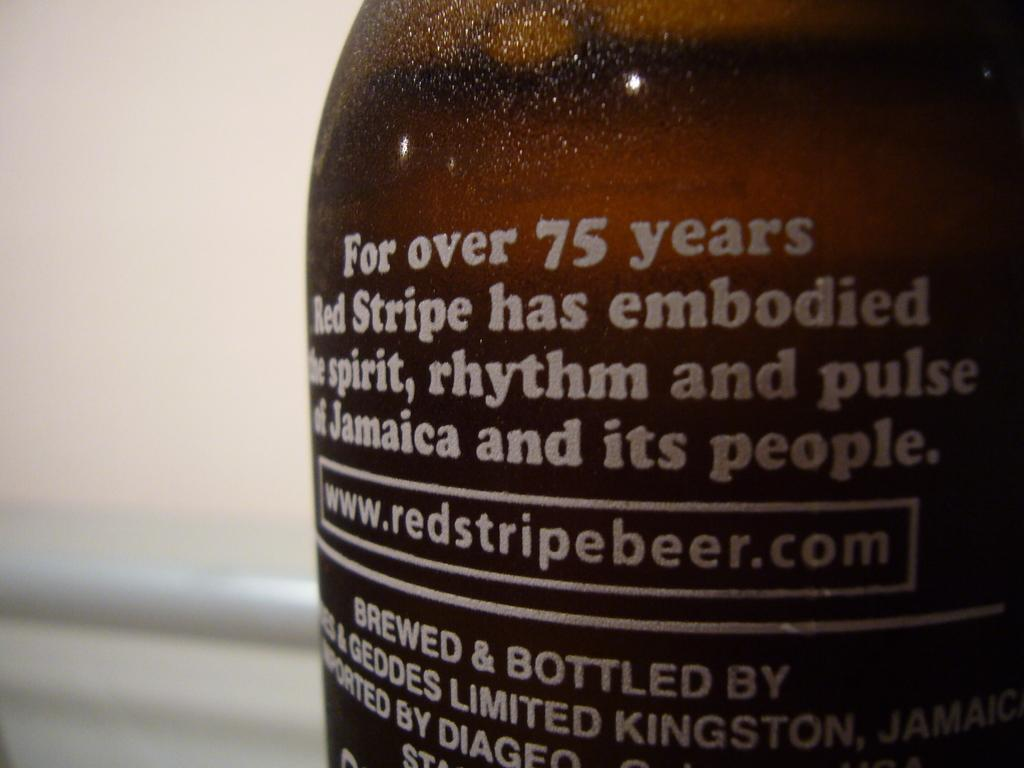<image>
Write a terse but informative summary of the picture. A bottle of Red Stripe beer that tells their website to be "www.redstripebeer.com". 